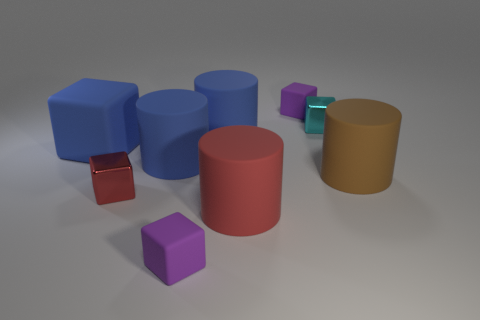Subtract all tiny red shiny blocks. How many blocks are left? 4 Subtract all red blocks. How many blocks are left? 4 Subtract 2 blocks. How many blocks are left? 3 Subtract all yellow cylinders. Subtract all blue spheres. How many cylinders are left? 4 Add 1 tiny metal things. How many objects exist? 10 Subtract all cylinders. How many objects are left? 5 Subtract all tiny green shiny blocks. Subtract all large blue matte cubes. How many objects are left? 8 Add 4 blue matte blocks. How many blue matte blocks are left? 5 Add 7 tiny gray metallic cylinders. How many tiny gray metallic cylinders exist? 7 Subtract 0 yellow spheres. How many objects are left? 9 